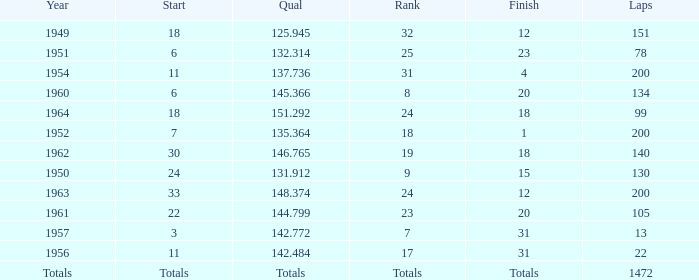Parse the full table. {'header': ['Year', 'Start', 'Qual', 'Rank', 'Finish', 'Laps'], 'rows': [['1949', '18', '125.945', '32', '12', '151'], ['1951', '6', '132.314', '25', '23', '78'], ['1954', '11', '137.736', '31', '4', '200'], ['1960', '6', '145.366', '8', '20', '134'], ['1964', '18', '151.292', '24', '18', '99'], ['1952', '7', '135.364', '18', '1', '200'], ['1962', '30', '146.765', '19', '18', '140'], ['1950', '24', '131.912', '9', '15', '130'], ['1963', '33', '148.374', '24', '12', '200'], ['1961', '22', '144.799', '23', '20', '105'], ['1957', '3', '142.772', '7', '31', '13'], ['1956', '11', '142.484', '17', '31', '22'], ['Totals', 'Totals', 'Totals', 'Totals', 'Totals', '1472']]} Name the rank for laps less than 130 and year of 1951 25.0. 